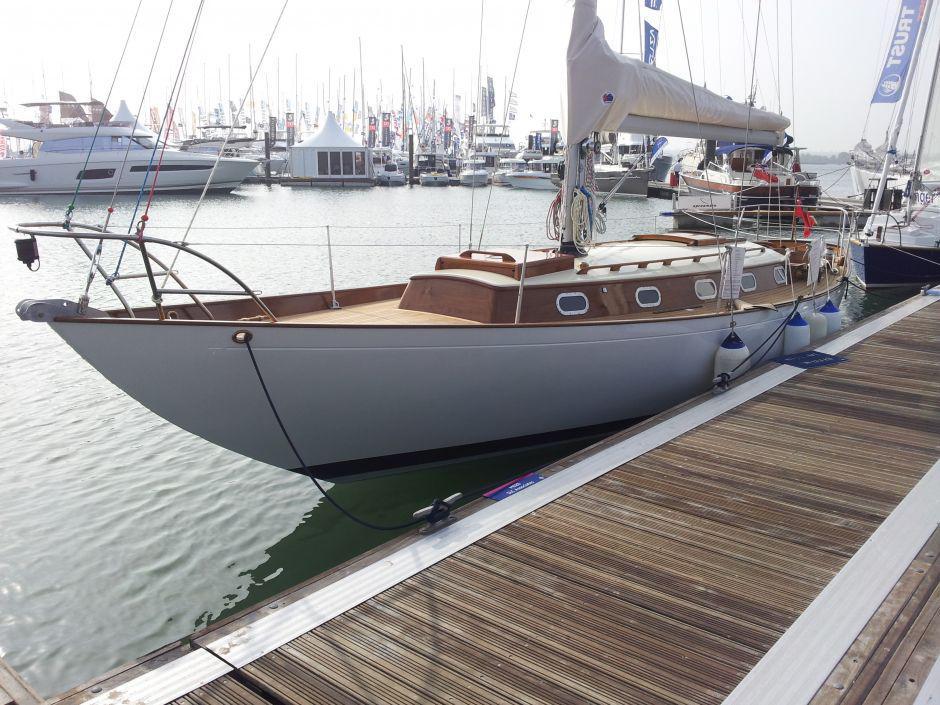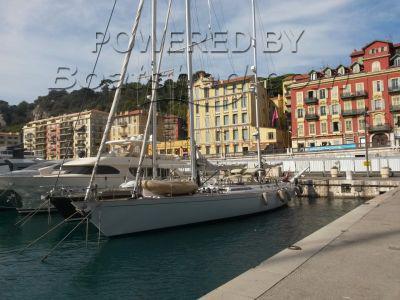The first image is the image on the left, the second image is the image on the right. Examine the images to the left and right. Is the description "The left and right image contains the same number of sailboats." accurate? Answer yes or no. No. The first image is the image on the left, the second image is the image on the right. For the images displayed, is the sentence "A boat in the right image is out of the water." factually correct? Answer yes or no. No. 